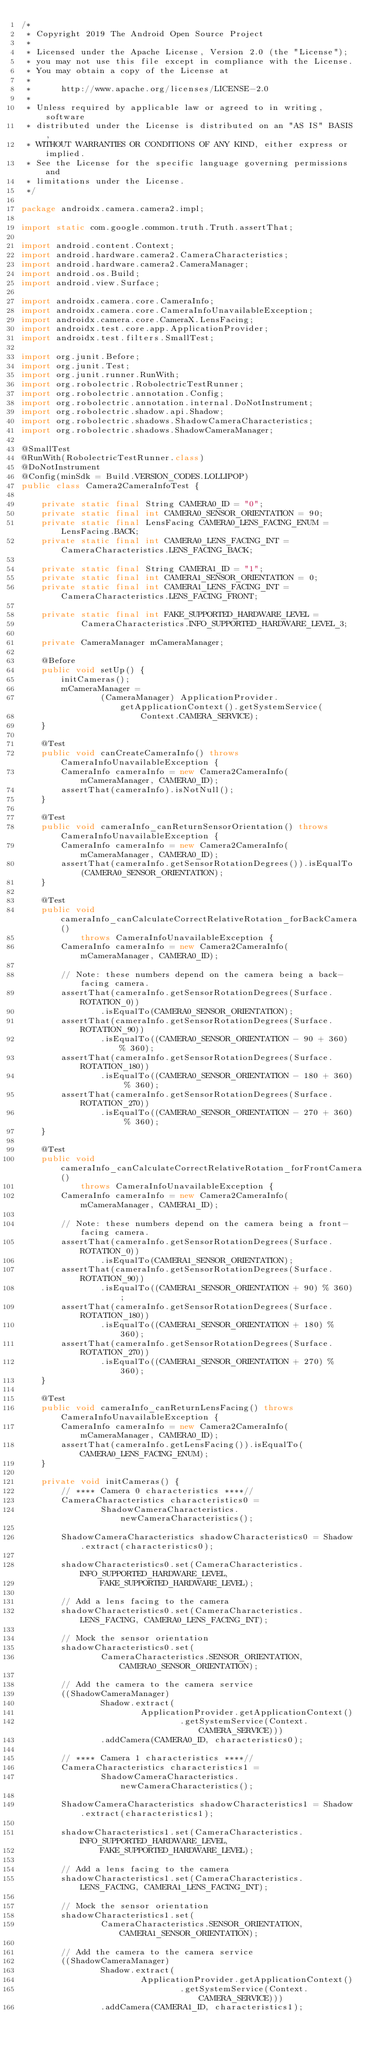Convert code to text. <code><loc_0><loc_0><loc_500><loc_500><_Java_>/*
 * Copyright 2019 The Android Open Source Project
 *
 * Licensed under the Apache License, Version 2.0 (the "License");
 * you may not use this file except in compliance with the License.
 * You may obtain a copy of the License at
 *
 *      http://www.apache.org/licenses/LICENSE-2.0
 *
 * Unless required by applicable law or agreed to in writing, software
 * distributed under the License is distributed on an "AS IS" BASIS,
 * WITHOUT WARRANTIES OR CONDITIONS OF ANY KIND, either express or implied.
 * See the License for the specific language governing permissions and
 * limitations under the License.
 */

package androidx.camera.camera2.impl;

import static com.google.common.truth.Truth.assertThat;

import android.content.Context;
import android.hardware.camera2.CameraCharacteristics;
import android.hardware.camera2.CameraManager;
import android.os.Build;
import android.view.Surface;

import androidx.camera.core.CameraInfo;
import androidx.camera.core.CameraInfoUnavailableException;
import androidx.camera.core.CameraX.LensFacing;
import androidx.test.core.app.ApplicationProvider;
import androidx.test.filters.SmallTest;

import org.junit.Before;
import org.junit.Test;
import org.junit.runner.RunWith;
import org.robolectric.RobolectricTestRunner;
import org.robolectric.annotation.Config;
import org.robolectric.annotation.internal.DoNotInstrument;
import org.robolectric.shadow.api.Shadow;
import org.robolectric.shadows.ShadowCameraCharacteristics;
import org.robolectric.shadows.ShadowCameraManager;

@SmallTest
@RunWith(RobolectricTestRunner.class)
@DoNotInstrument
@Config(minSdk = Build.VERSION_CODES.LOLLIPOP)
public class Camera2CameraInfoTest {

    private static final String CAMERA0_ID = "0";
    private static final int CAMERA0_SENSOR_ORIENTATION = 90;
    private static final LensFacing CAMERA0_LENS_FACING_ENUM = LensFacing.BACK;
    private static final int CAMERA0_LENS_FACING_INT = CameraCharacteristics.LENS_FACING_BACK;

    private static final String CAMERA1_ID = "1";
    private static final int CAMERA1_SENSOR_ORIENTATION = 0;
    private static final int CAMERA1_LENS_FACING_INT = CameraCharacteristics.LENS_FACING_FRONT;

    private static final int FAKE_SUPPORTED_HARDWARE_LEVEL =
            CameraCharacteristics.INFO_SUPPORTED_HARDWARE_LEVEL_3;

    private CameraManager mCameraManager;

    @Before
    public void setUp() {
        initCameras();
        mCameraManager =
                (CameraManager) ApplicationProvider.getApplicationContext().getSystemService(
                        Context.CAMERA_SERVICE);
    }

    @Test
    public void canCreateCameraInfo() throws CameraInfoUnavailableException {
        CameraInfo cameraInfo = new Camera2CameraInfo(mCameraManager, CAMERA0_ID);
        assertThat(cameraInfo).isNotNull();
    }

    @Test
    public void cameraInfo_canReturnSensorOrientation() throws CameraInfoUnavailableException {
        CameraInfo cameraInfo = new Camera2CameraInfo(mCameraManager, CAMERA0_ID);
        assertThat(cameraInfo.getSensorRotationDegrees()).isEqualTo(CAMERA0_SENSOR_ORIENTATION);
    }

    @Test
    public void cameraInfo_canCalculateCorrectRelativeRotation_forBackCamera()
            throws CameraInfoUnavailableException {
        CameraInfo cameraInfo = new Camera2CameraInfo(mCameraManager, CAMERA0_ID);

        // Note: these numbers depend on the camera being a back-facing camera.
        assertThat(cameraInfo.getSensorRotationDegrees(Surface.ROTATION_0))
                .isEqualTo(CAMERA0_SENSOR_ORIENTATION);
        assertThat(cameraInfo.getSensorRotationDegrees(Surface.ROTATION_90))
                .isEqualTo((CAMERA0_SENSOR_ORIENTATION - 90 + 360) % 360);
        assertThat(cameraInfo.getSensorRotationDegrees(Surface.ROTATION_180))
                .isEqualTo((CAMERA0_SENSOR_ORIENTATION - 180 + 360) % 360);
        assertThat(cameraInfo.getSensorRotationDegrees(Surface.ROTATION_270))
                .isEqualTo((CAMERA0_SENSOR_ORIENTATION - 270 + 360) % 360);
    }

    @Test
    public void cameraInfo_canCalculateCorrectRelativeRotation_forFrontCamera()
            throws CameraInfoUnavailableException {
        CameraInfo cameraInfo = new Camera2CameraInfo(mCameraManager, CAMERA1_ID);

        // Note: these numbers depend on the camera being a front-facing camera.
        assertThat(cameraInfo.getSensorRotationDegrees(Surface.ROTATION_0))
                .isEqualTo(CAMERA1_SENSOR_ORIENTATION);
        assertThat(cameraInfo.getSensorRotationDegrees(Surface.ROTATION_90))
                .isEqualTo((CAMERA1_SENSOR_ORIENTATION + 90) % 360);
        assertThat(cameraInfo.getSensorRotationDegrees(Surface.ROTATION_180))
                .isEqualTo((CAMERA1_SENSOR_ORIENTATION + 180) % 360);
        assertThat(cameraInfo.getSensorRotationDegrees(Surface.ROTATION_270))
                .isEqualTo((CAMERA1_SENSOR_ORIENTATION + 270) % 360);
    }

    @Test
    public void cameraInfo_canReturnLensFacing() throws CameraInfoUnavailableException {
        CameraInfo cameraInfo = new Camera2CameraInfo(mCameraManager, CAMERA0_ID);
        assertThat(cameraInfo.getLensFacing()).isEqualTo(CAMERA0_LENS_FACING_ENUM);
    }

    private void initCameras() {
        // **** Camera 0 characteristics ****//
        CameraCharacteristics characteristics0 =
                ShadowCameraCharacteristics.newCameraCharacteristics();

        ShadowCameraCharacteristics shadowCharacteristics0 = Shadow.extract(characteristics0);

        shadowCharacteristics0.set(CameraCharacteristics.INFO_SUPPORTED_HARDWARE_LEVEL,
                FAKE_SUPPORTED_HARDWARE_LEVEL);

        // Add a lens facing to the camera
        shadowCharacteristics0.set(CameraCharacteristics.LENS_FACING, CAMERA0_LENS_FACING_INT);

        // Mock the sensor orientation
        shadowCharacteristics0.set(
                CameraCharacteristics.SENSOR_ORIENTATION, CAMERA0_SENSOR_ORIENTATION);

        // Add the camera to the camera service
        ((ShadowCameraManager)
                Shadow.extract(
                        ApplicationProvider.getApplicationContext()
                                .getSystemService(Context.CAMERA_SERVICE)))
                .addCamera(CAMERA0_ID, characteristics0);

        // **** Camera 1 characteristics ****//
        CameraCharacteristics characteristics1 =
                ShadowCameraCharacteristics.newCameraCharacteristics();

        ShadowCameraCharacteristics shadowCharacteristics1 = Shadow.extract(characteristics1);

        shadowCharacteristics1.set(CameraCharacteristics.INFO_SUPPORTED_HARDWARE_LEVEL,
                FAKE_SUPPORTED_HARDWARE_LEVEL);

        // Add a lens facing to the camera
        shadowCharacteristics1.set(CameraCharacteristics.LENS_FACING, CAMERA1_LENS_FACING_INT);

        // Mock the sensor orientation
        shadowCharacteristics1.set(
                CameraCharacteristics.SENSOR_ORIENTATION, CAMERA1_SENSOR_ORIENTATION);

        // Add the camera to the camera service
        ((ShadowCameraManager)
                Shadow.extract(
                        ApplicationProvider.getApplicationContext()
                                .getSystemService(Context.CAMERA_SERVICE)))
                .addCamera(CAMERA1_ID, characteristics1);</code> 